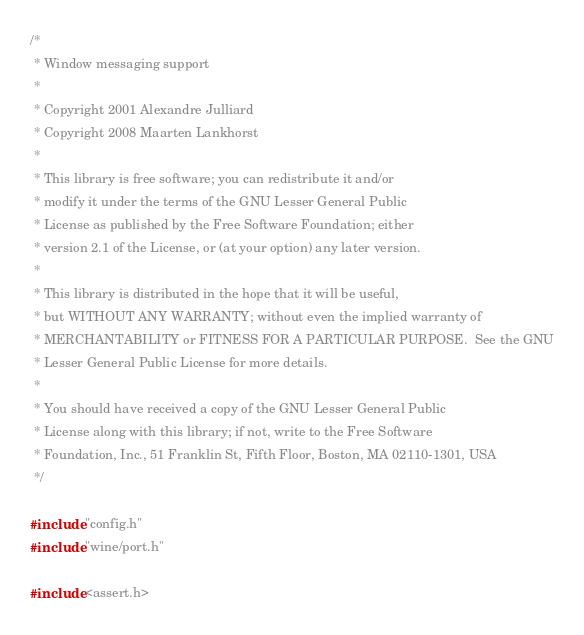Convert code to text. <code><loc_0><loc_0><loc_500><loc_500><_C_>/*
 * Window messaging support
 *
 * Copyright 2001 Alexandre Julliard
 * Copyright 2008 Maarten Lankhorst
 *
 * This library is free software; you can redistribute it and/or
 * modify it under the terms of the GNU Lesser General Public
 * License as published by the Free Software Foundation; either
 * version 2.1 of the License, or (at your option) any later version.
 *
 * This library is distributed in the hope that it will be useful,
 * but WITHOUT ANY WARRANTY; without even the implied warranty of
 * MERCHANTABILITY or FITNESS FOR A PARTICULAR PURPOSE.  See the GNU
 * Lesser General Public License for more details.
 *
 * You should have received a copy of the GNU Lesser General Public
 * License along with this library; if not, write to the Free Software
 * Foundation, Inc., 51 Franklin St, Fifth Floor, Boston, MA 02110-1301, USA
 */

#include "config.h"
#include "wine/port.h"

#include <assert.h></code> 